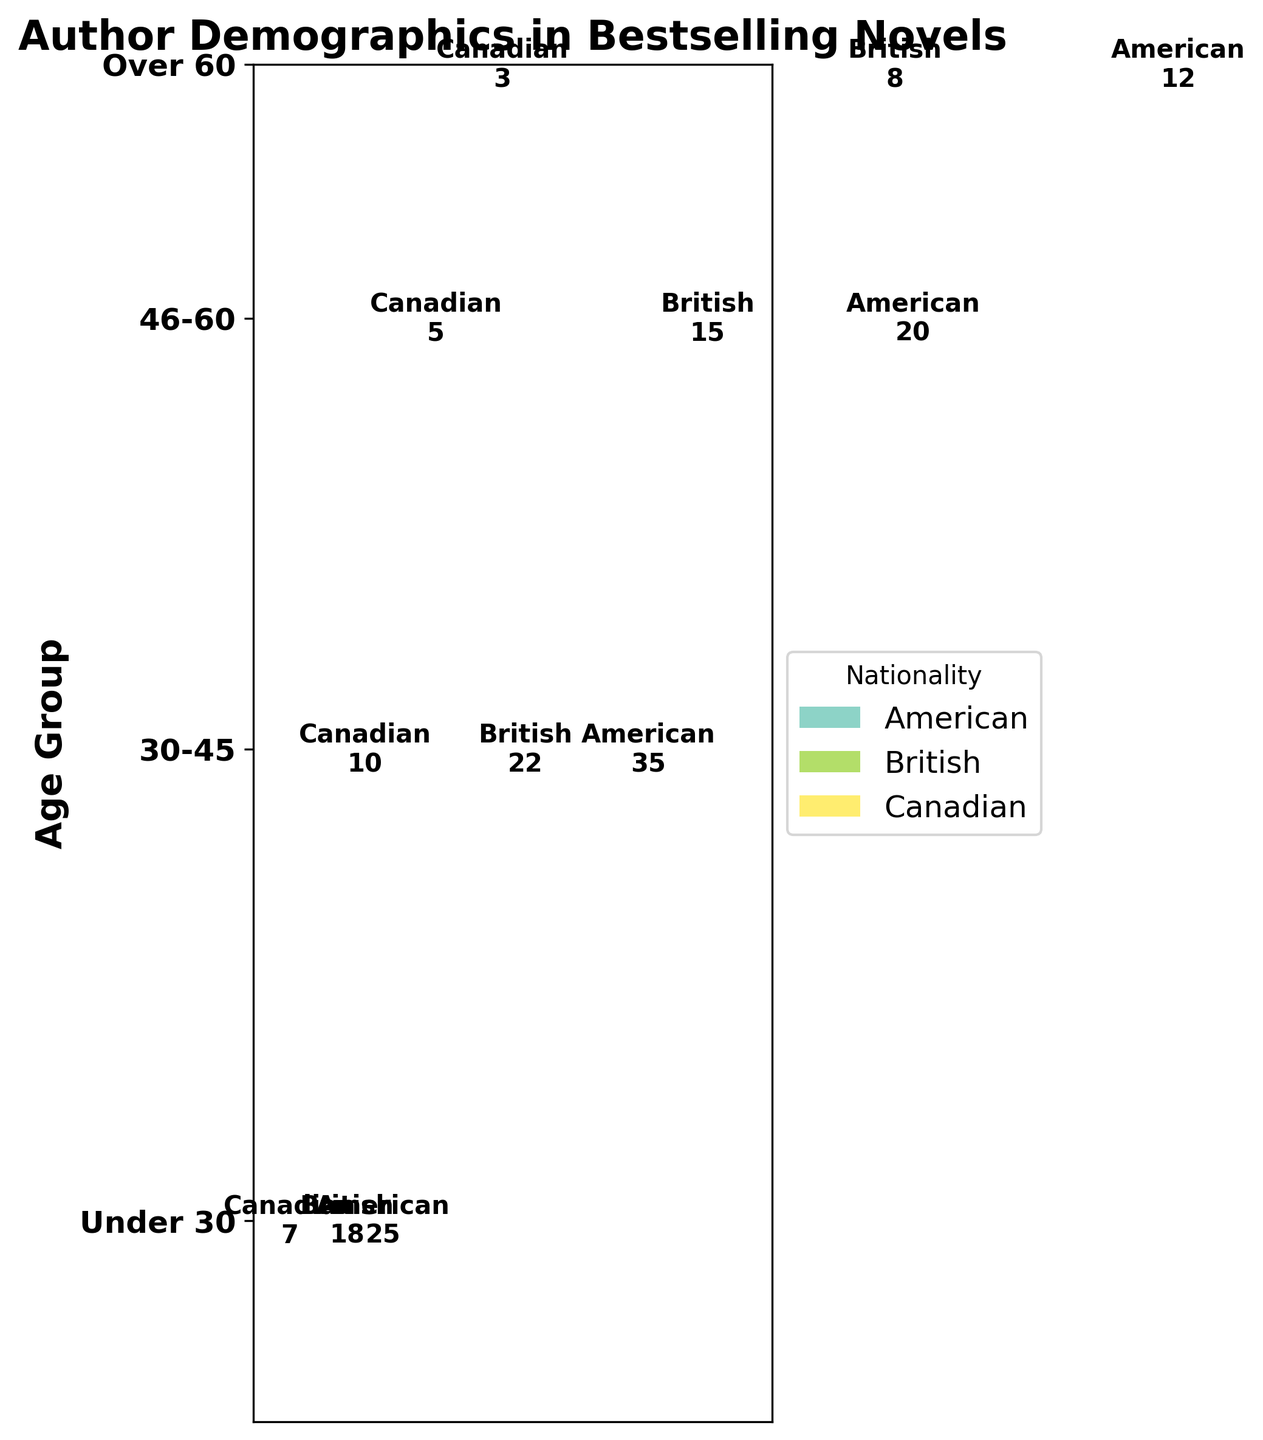What is the title of the plot? The title is located at the top of the plot. It reads "Author Demographics in Bestselling Novels".
Answer: Author Demographics in Bestselling Novels Which age group has the highest representation of American authors? By looking at the 'Age Group' labels on the y-axis and the corresponding parts of the mosaic plot, we observe that the block labelled "American" is largest in the age group "46-60".
Answer: 46-60 How many British authors are there in the "30-45" age group? Locate the "30-45" age group, then observe the portion of the plot colored to indicate British authors. The number in this section is "18".
Answer: 18 What age group has the smallest contribution from Canadian authors? Look at the sections labelled "Canadian" and compare their sizes across age groups. The "Under 30" and "Over 60" age groups have the smallest sections for Canadian authors, both showing the number "5".
Answer: Under 30 and Over 60 Compare the number of American authors in the "Under 30" and "Over 60" age groups. Which is larger? Look at the mosaic plot sections corresponding to American authors in both age groups. "Under 30" has a count of 12, while "Over 60" shows a count of 20. Therefore, the "Over 60" group is larger.
Answer: Over 60 How does the proportion of British authors in the "46-60" age group compare to the "30-45" age group? Calculate the proportions of British authors in these age groups by dividing their counts by the total counts in the respective groups. For the "46-60" age group (22/67), for "30-45" (18/50). Comparing these values, the proportion for "46-60" is slightly larger.
Answer: 46-60 Proportion: ~0.33, 30-45 Proportion: ~0.36, "46-60" In which age group do Canadian authors make up the highest proportion of authors? Calculate the proportion of Canadian authors in each age group by dividing the counts by the total counts. Under 30: 3/23, 30-45: 7/50, 46-60: 10/67, Over 60: 5/40. The highest proportion is in the "46-60" group.
Answer: 46-60 By how much does the number of British authors in the "46-60" age group exceed the number of Canadian authors in the same age group? Subtract the count of Canadian authors from the count of British authors for the "46-60" age group: 22 - 10 = 12.
Answer: 12 Which nationality has the overall highest number of authors across all age groups? Sum the counts for each nationality across all age groups. American: 92, British: 63, Canadian: 25. The American authors have the highest overall count.
Answer: American What is the total number of authors represented in the dataset? Sum the counts of all authors across age groups and nationalities. Total: 12+8+3+25+18+7+35+22+10+20+15+5 = 180.
Answer: 180 